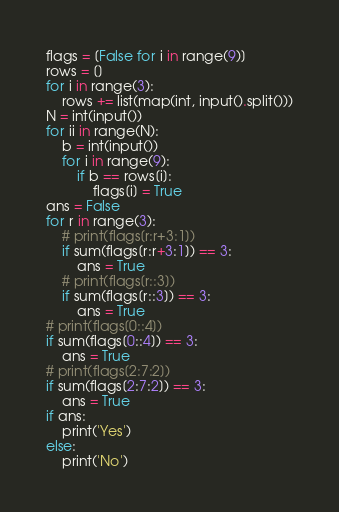Convert code to text. <code><loc_0><loc_0><loc_500><loc_500><_Python_>flags = [False for i in range(9)]
rows = []
for i in range(3):
    rows += list(map(int, input().split()))
N = int(input())
for ii in range(N):
    b = int(input())
    for i in range(9):
        if b == rows[i]:
            flags[i] = True
ans = False
for r in range(3):
    # print(flags[r:r+3:1])
    if sum(flags[r:r+3:1]) == 3:
        ans = True
    # print(flags[r::3])
    if sum(flags[r::3]) == 3:
        ans = True
# print(flags[0::4])
if sum(flags[0::4]) == 3:
    ans = True
# print(flags[2:7:2])
if sum(flags[2:7:2]) == 3:
    ans = True
if ans:
    print('Yes')
else:
    print('No')</code> 